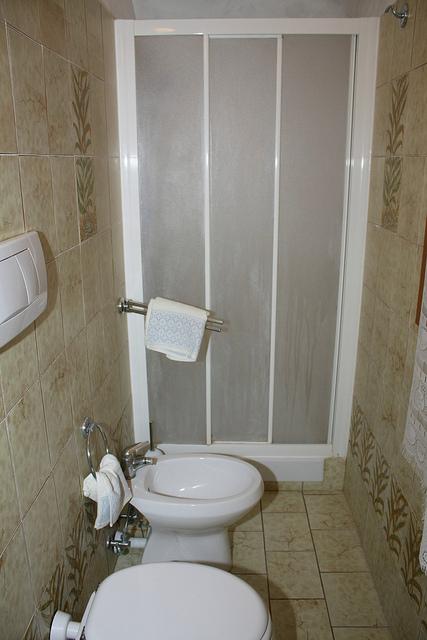What is behind the toilet?
Concise answer only. Shower. Does this bathroom need to be fixed?
Give a very brief answer. No. Is this a large bathroom?
Short answer required. No. Does this bathroom look clean?
Concise answer only. Yes. How many towels are there?
Be succinct. 2. 